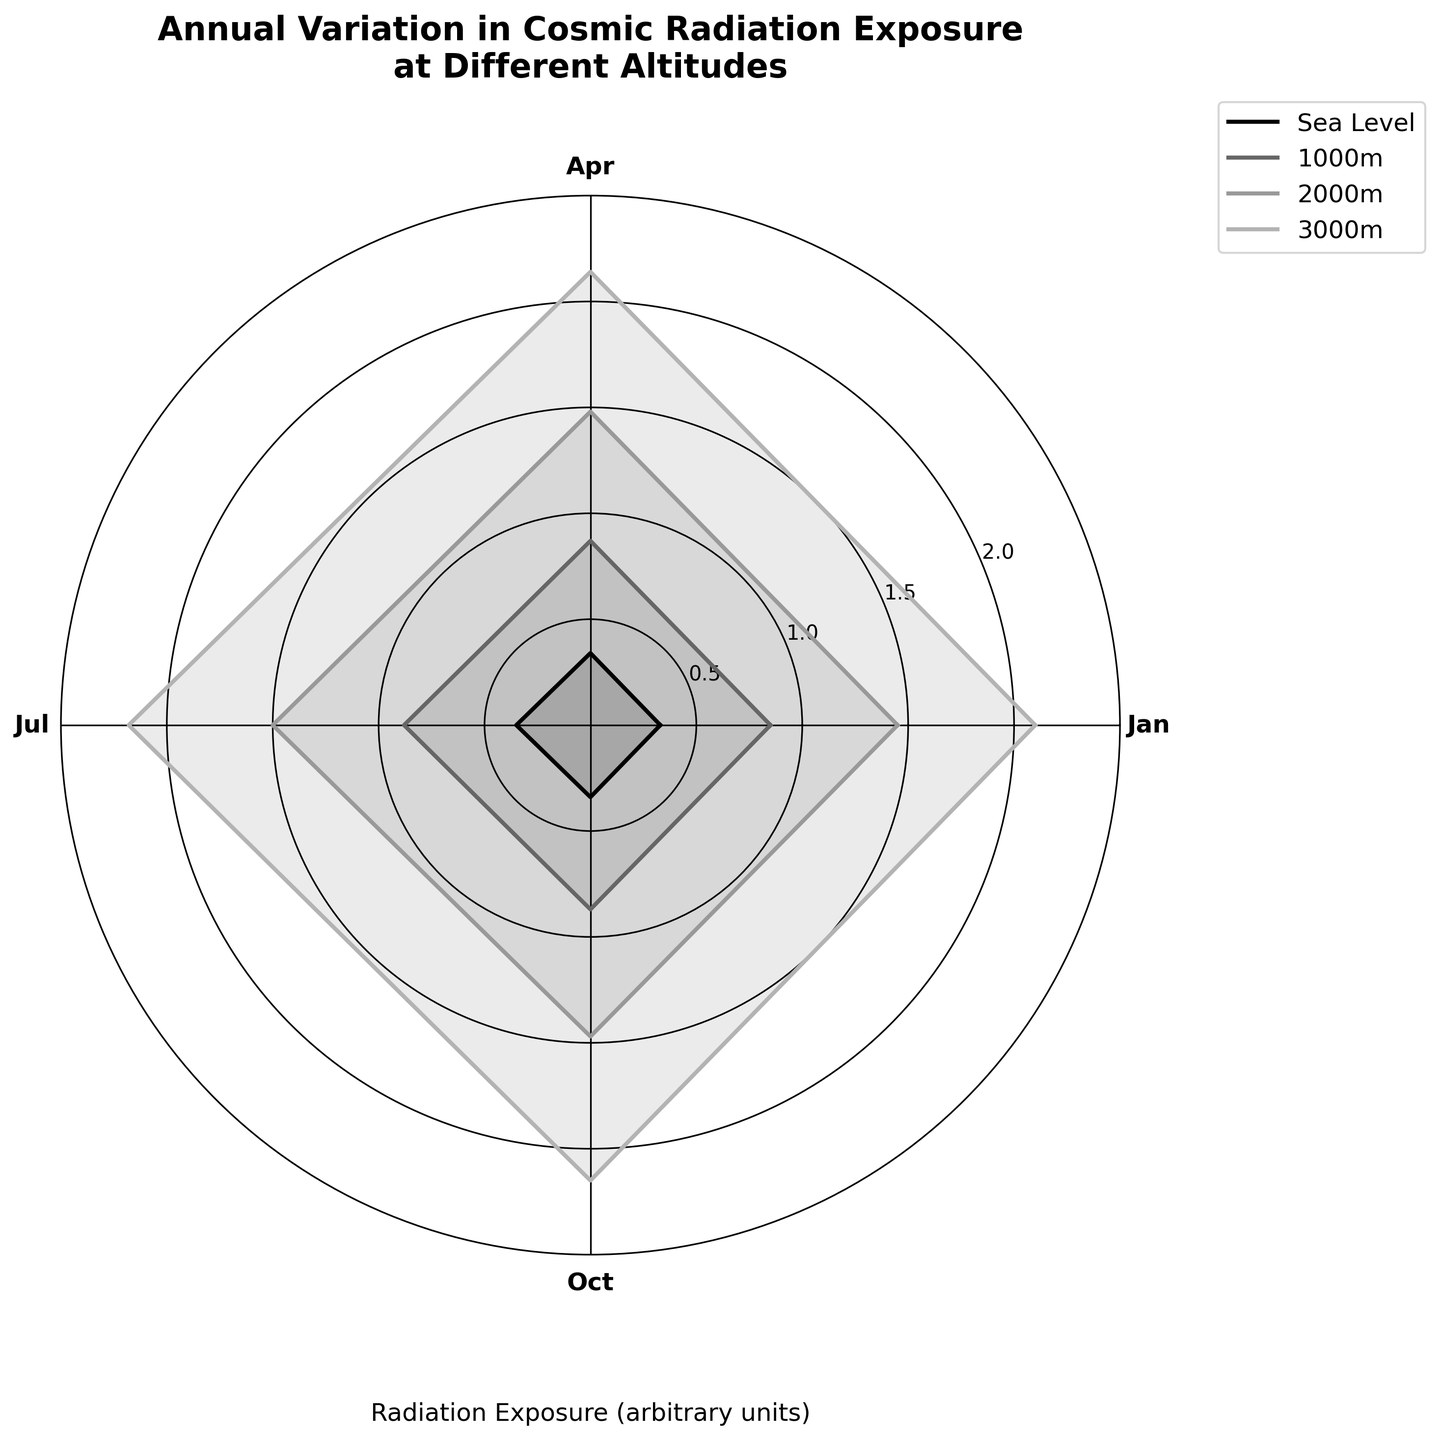What is the title of the chart? The title is placed at the top of the chart. It reads "Annual Variation in Cosmic Radiation Exposure at Different Altitudes".
Answer: Annual Variation in Cosmic Radiation Exposure at Different Altitudes What is the radiation exposure at sea level in January? Locate the data point corresponding to sea level in January. Refer to the plot or use the dataset.
Answer: 0.33 Which altitude shows the highest radiation exposure in July? Compare the radiation exposure values in July for all altitudes. Lhasa at 3000m has the highest value.
Answer: Lhasa (3000m) What is the most common radiation exposure value at 1000m altitude across all months? Look at the four data points for 1000m altitude. The values are 0.85, 0.87, 0.88, and 0.87. The mode is 0.87.
Answer: 0.87 What is the average radiation exposure at 2000m across all months? Sum the radiation exposures at 2000m for Jan, Apr, Jul, and Oct. (1.45 + 1.48 + 1.50 + 1.47)/4 = 1.475.
Answer: 1.475 How does the radiation exposure at 3000m in January compare to April? Compare the data points for 3000m in January and April. January is 2.10 and April is 2.14. April has a higher value.
Answer: April is higher Which location has the most consistent radiation exposure over the year? Examine the variability in radiation exposure for each location across all months. New York at sea level has the smallest variation from 0.33 to 0.35.
Answer: New York (Sea Level) What is the difference in radiation exposure between October and January at 1000m altitude? Subtract the January value from the October value for 1000m. 0.87 - 0.85 = 0.02.
Answer: 0.02 What pattern do you observe over the year for Lhasa at 3000m? Note how the values change over the months for Lhasa. Radiation increases from Jan to Jul and then slightly decreases in Oct.
Answer: Increase, then slight decrease Which month generally shows the highest radiation exposure across all altitudes? Look at the values for all altitudes in each month. July generally has the highest exposure.
Answer: July 